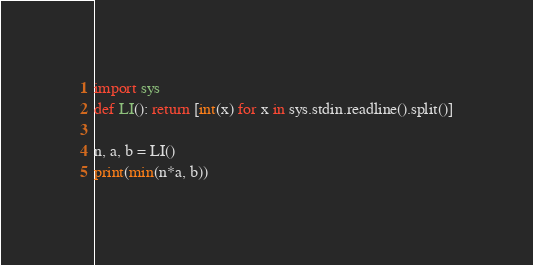Convert code to text. <code><loc_0><loc_0><loc_500><loc_500><_Python_>import sys
def LI(): return [int(x) for x in sys.stdin.readline().split()]

n, a, b = LI()
print(min(n*a, b))</code> 